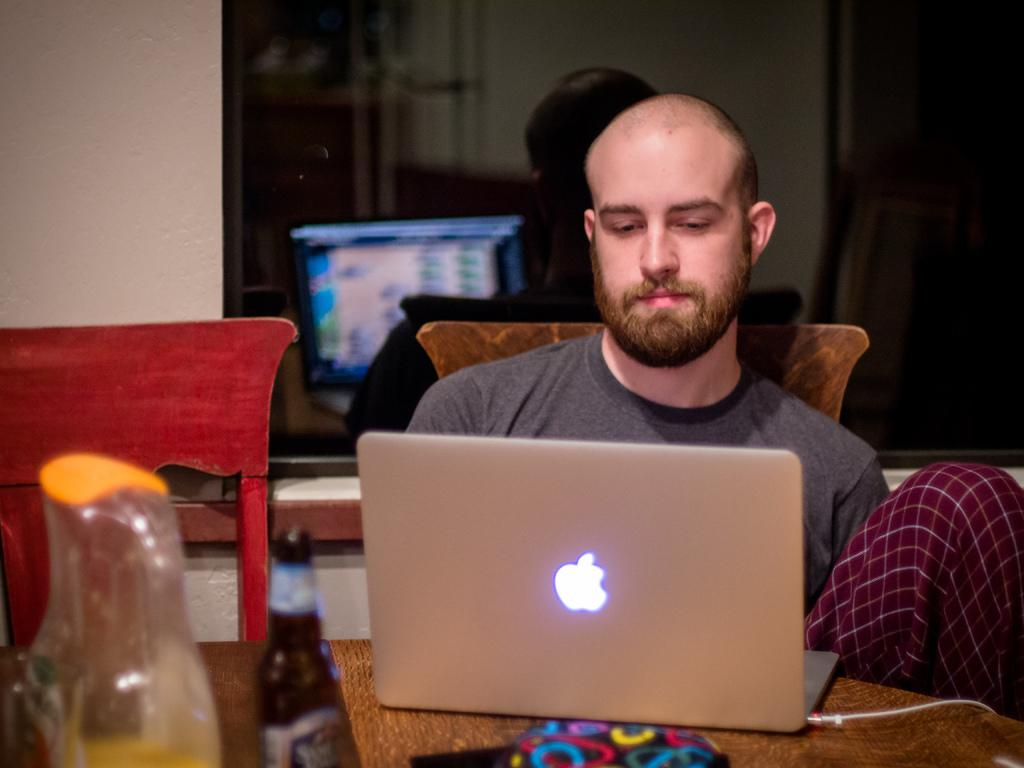What is the person in the image doing? The person in the image is working on a laptop. What object can be seen on the left side of the image? There is a glass bottle on the left side of the image. What piece of furniture is present in the image? There is a chair in the image. What part of the laptop is visible in the image? The laptop screen is visible in the background of the image. What type of ship can be seen sailing in the background of the image? There is no ship present in the image; it features a person working on a laptop, a glass bottle, and a chair. 